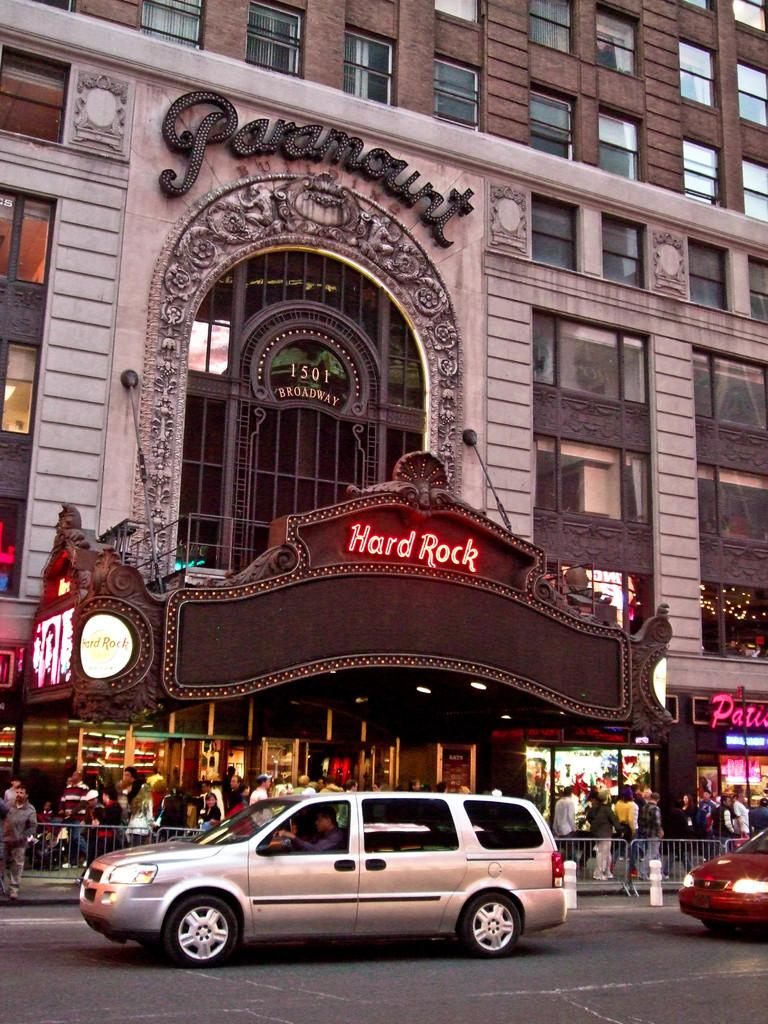What is the main feature of the image? There is a road in the image. What else can be seen on the road? There are vehicles in the image. What are the people in the image doing? People are walking in the image. What can be seen in the distance in the image? There are buildings in the background of the image. What is written or visible in the background? There is some text visible in the background. What type of windows are present in the image? There are windows with glasses in the image. Can you see any tin waves in the image? There are no tin waves present in the image. 